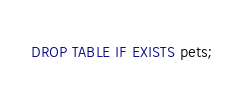<code> <loc_0><loc_0><loc_500><loc_500><_SQL_>DROP TABLE IF EXISTS pets;</code> 